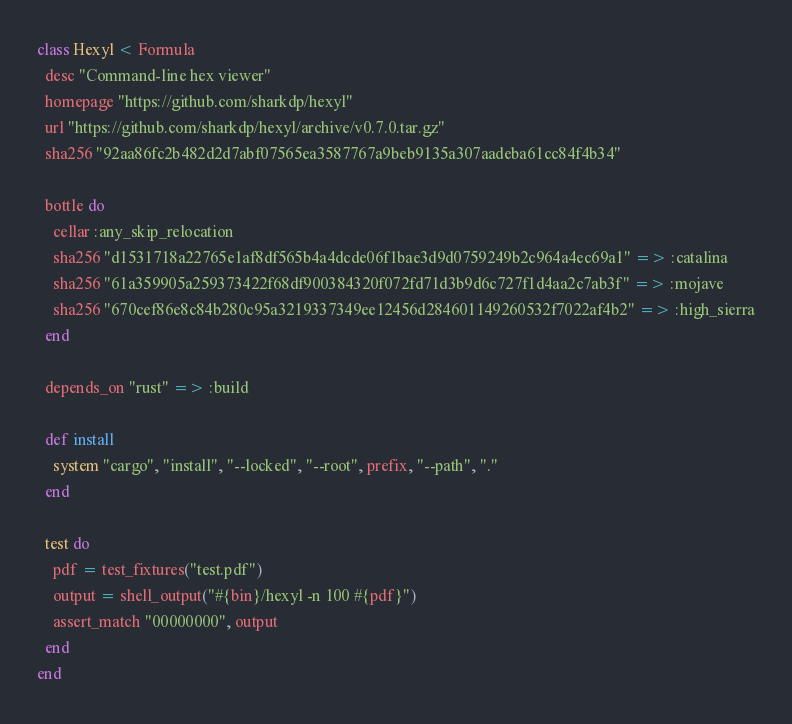<code> <loc_0><loc_0><loc_500><loc_500><_Ruby_>class Hexyl < Formula
  desc "Command-line hex viewer"
  homepage "https://github.com/sharkdp/hexyl"
  url "https://github.com/sharkdp/hexyl/archive/v0.7.0.tar.gz"
  sha256 "92aa86fc2b482d2d7abf07565ea3587767a9beb9135a307aadeba61cc84f4b34"

  bottle do
    cellar :any_skip_relocation
    sha256 "d1531718a22765e1af8df565b4a4dcde06f1bae3d9d0759249b2c964a4ec69a1" => :catalina
    sha256 "61a359905a259373422f68df900384320f072fd71d3b9d6c727f1d4aa2c7ab3f" => :mojave
    sha256 "670cef86e8c84b280c95a3219337349ee12456d284601149260532f7022af4b2" => :high_sierra
  end

  depends_on "rust" => :build

  def install
    system "cargo", "install", "--locked", "--root", prefix, "--path", "."
  end

  test do
    pdf = test_fixtures("test.pdf")
    output = shell_output("#{bin}/hexyl -n 100 #{pdf}")
    assert_match "00000000", output
  end
end
</code> 